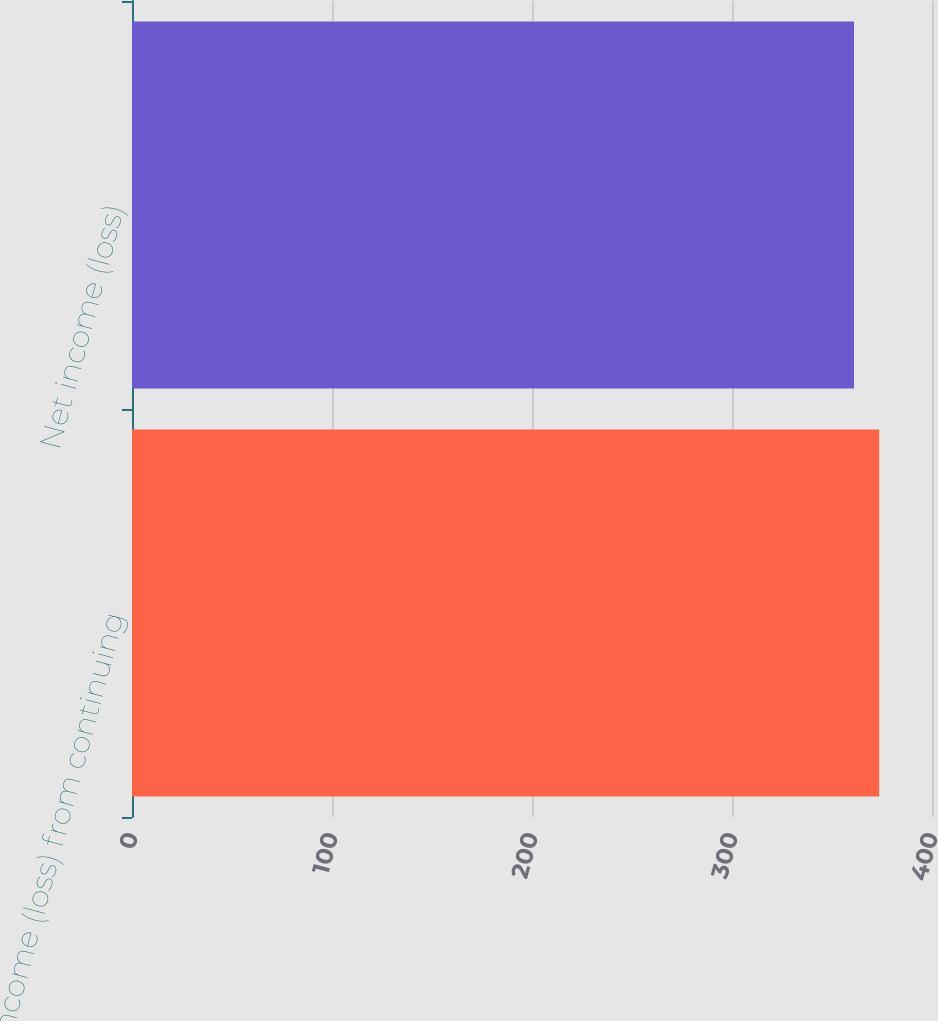<chart> <loc_0><loc_0><loc_500><loc_500><bar_chart><fcel>Income (loss) from continuing<fcel>Net income (loss)<nl><fcel>373.6<fcel>361<nl></chart> 